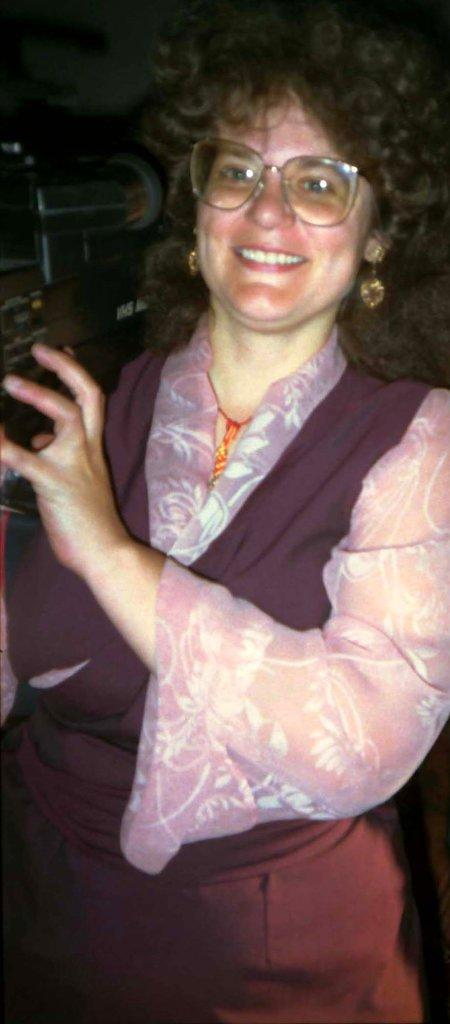What is the main subject of the image? The main subject of the image is a woman. What is the woman holding in the image? The woman is holding a video camera. Where is the woman's grandfather in the image? There is no mention of a grandfather in the image, so it cannot be determined if he is present or not. 